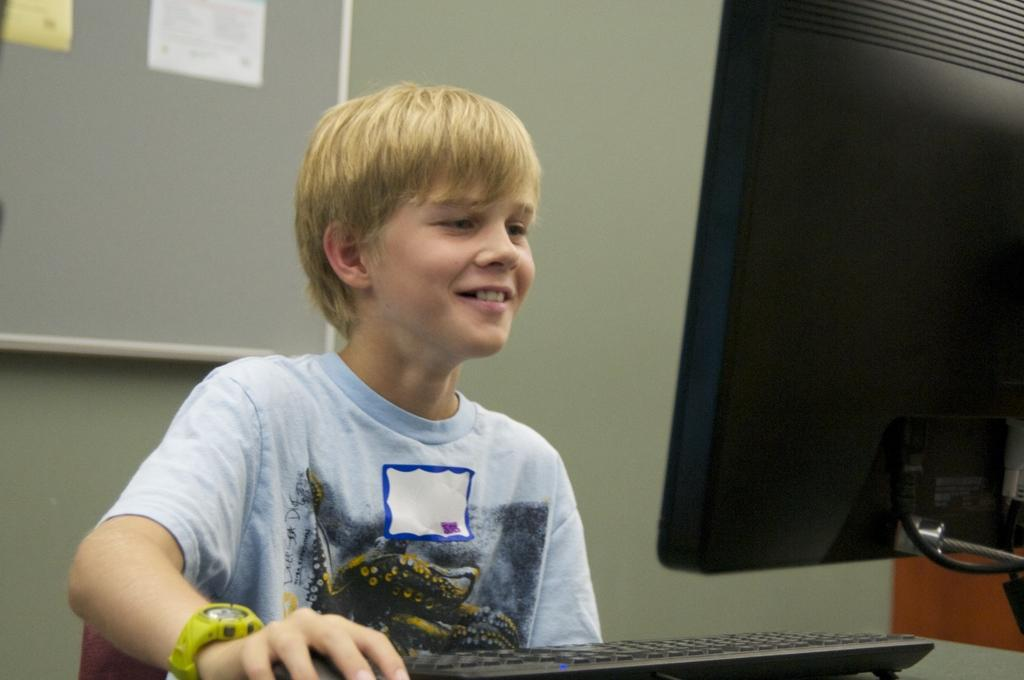Who is in the image? There is a boy in the image. What is the boy doing? The boy is smiling. What objects are in front of the boy? There is a monitor and a keyboard in front of the boy. What can be seen on the notice board behind the boy? There are papers on a notice board behind the boy. What is the price of the word "hello" on the monitor? There is no price or word "hello" present on the monitor in the image. 